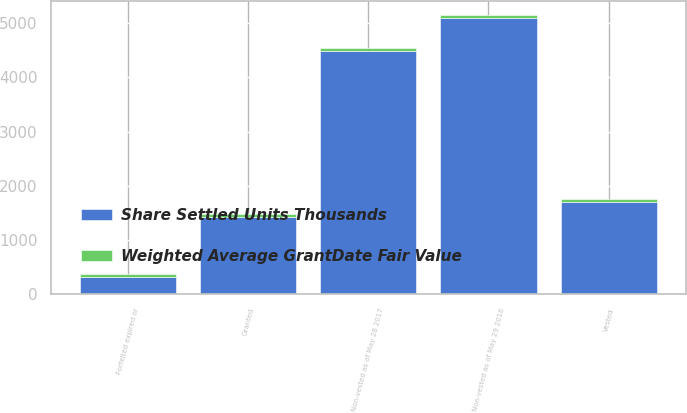Convert chart. <chart><loc_0><loc_0><loc_500><loc_500><stacked_bar_chart><ecel><fcel>Non-vested as of May 29 2016<fcel>Granted<fcel>Vested<fcel>Forfeited expired or<fcel>Non-vested as of May 28 2017<nl><fcel>Share Settled Units Thousands<fcel>5100.4<fcel>1418.7<fcel>1710.3<fcel>317.6<fcel>4491.2<nl><fcel>Weighted Average GrantDate Fair Value<fcel>48.6<fcel>67.02<fcel>42.5<fcel>57.96<fcel>56.08<nl></chart> 